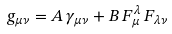Convert formula to latex. <formula><loc_0><loc_0><loc_500><loc_500>g _ { \mu \nu } = A \, \gamma _ { \mu \nu } + B \, F _ { \mu } ^ { \lambda } \, F _ { \lambda \nu }</formula> 